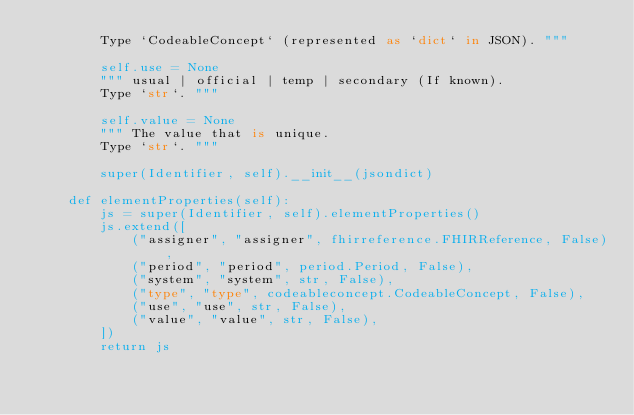<code> <loc_0><loc_0><loc_500><loc_500><_Python_>        Type `CodeableConcept` (represented as `dict` in JSON). """
        
        self.use = None
        """ usual | official | temp | secondary (If known).
        Type `str`. """
        
        self.value = None
        """ The value that is unique.
        Type `str`. """
        
        super(Identifier, self).__init__(jsondict)
    
    def elementProperties(self):
        js = super(Identifier, self).elementProperties()
        js.extend([
            ("assigner", "assigner", fhirreference.FHIRReference, False),
            ("period", "period", period.Period, False),
            ("system", "system", str, False),
            ("type", "type", codeableconcept.CodeableConcept, False),
            ("use", "use", str, False),
            ("value", "value", str, False),
        ])
        return js

</code> 